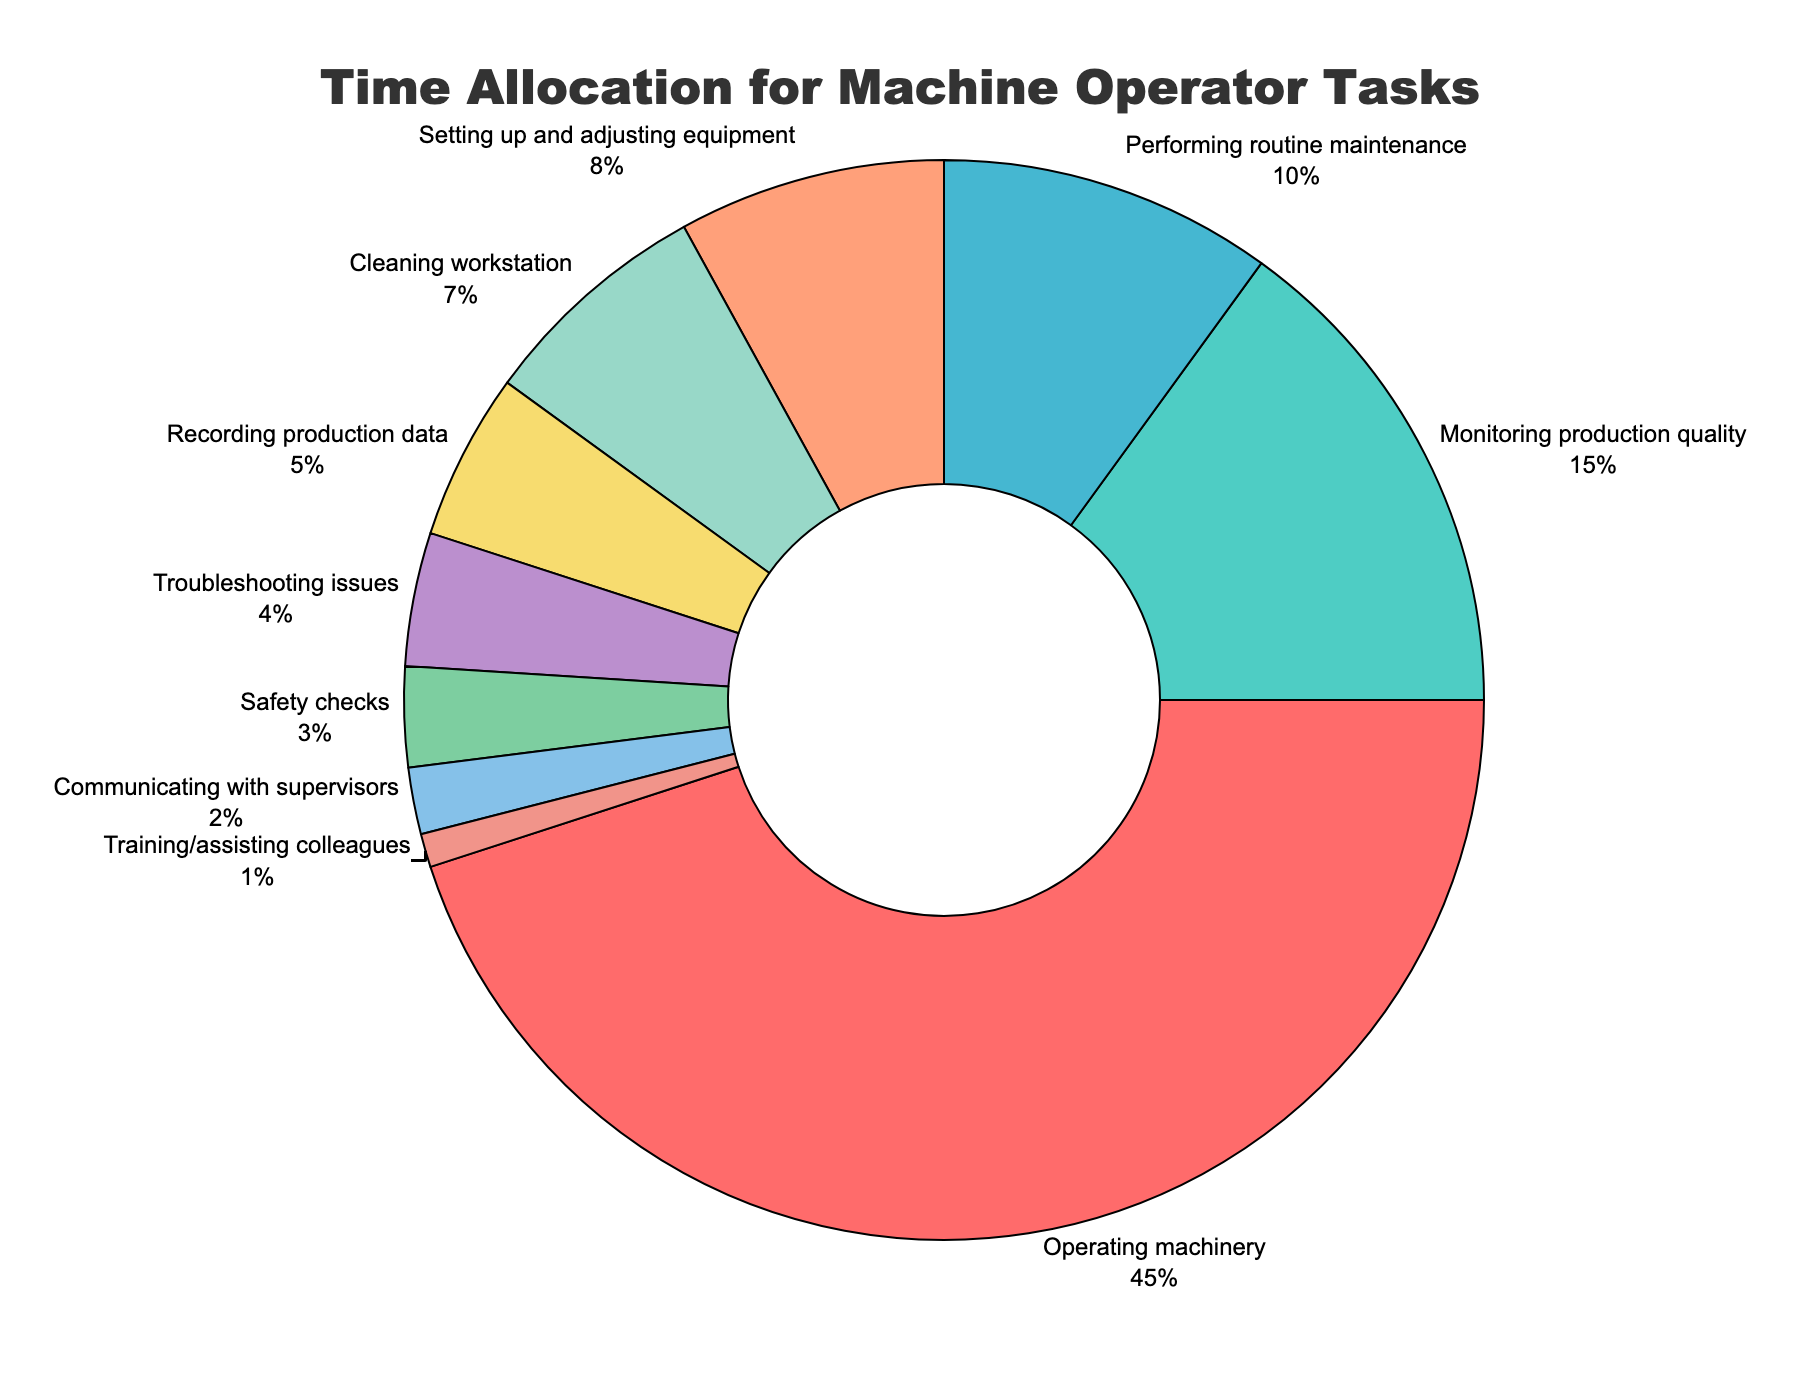What percentage of time is spent on monitoring production quality? The pie chart displays different tasks and their respective percentages. Locate the segment labeled 'Monitoring production quality' and note the percentage.
Answer: 15% How much more time is spent on operating machinery compared to performing routine maintenance? Identify the percentages for 'Operating machinery' (45%) and 'Performing routine maintenance' (10%). Subtract the latter from the former: 45% - 10% = 35%.
Answer: 35% Which task has the smallest allocation of time? Locate the segment with the smallest percentage on the pie chart. The label for this segment is 'Training/assisting colleagues.'
Answer: Training/assisting colleagues How much total time is allocated to safety checks and troubleshooting issues together? Identify the percentages for 'Safety checks' (3%) and 'Troubleshooting issues' (4%). Add these percentages together: 3% + 4% = 7%.
Answer: 7% Is more time spent on setting up and adjusting equipment or cleaning the workstation? Compare the percentages for 'Setting up and adjusting equipment' (8%) and 'Cleaning workstation' (7%). Note that 8% > 7%.
Answer: Setting up and adjusting equipment What task occupies a time allocation percentage directly between communicating with supervisors and performing routine maintenance? Identify the percentages for 'Communicating with supervisors' (2%), 'Performing routine maintenance' (10%), and the segment directly between these two, 'Recording production data' (5%).
Answer: Recording production data Which task takes up as much time as cleaning the workstation and communicating with supervisors combined? Identify the percentages for 'Cleaning workstation' (7%) and 'Communicating with supervisors' (2%). Add these percentages together: 7% + 2% = 9%. Then find the segment that matches this total, which is 'Setting up and adjusting equipment' (8%) is the closest.
Answer: Setting up and adjusting equipment What is the color of the segment representing performing routine maintenance? Identify the segment labeled 'Performing routine maintenance' and observe its color.
Answer: Light blue 